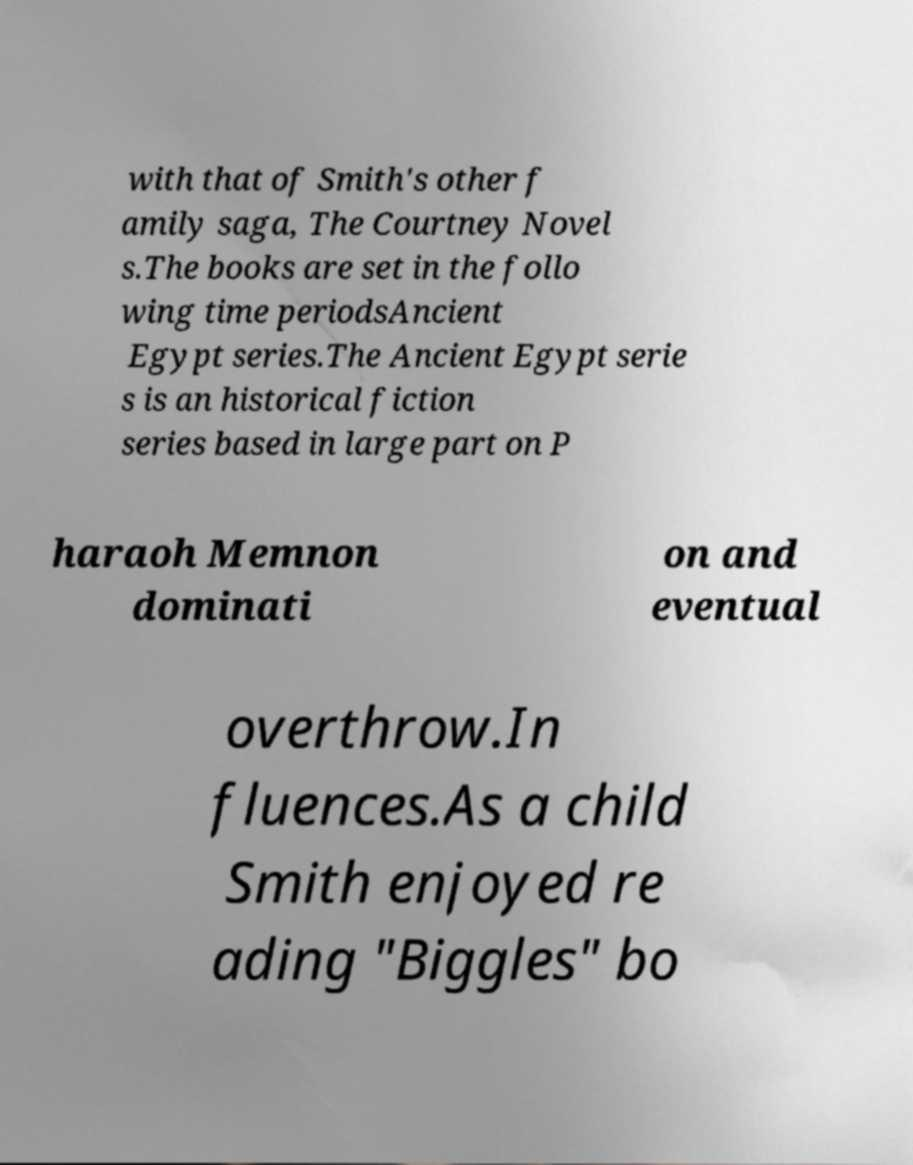For documentation purposes, I need the text within this image transcribed. Could you provide that? with that of Smith's other f amily saga, The Courtney Novel s.The books are set in the follo wing time periodsAncient Egypt series.The Ancient Egypt serie s is an historical fiction series based in large part on P haraoh Memnon dominati on and eventual overthrow.In fluences.As a child Smith enjoyed re ading "Biggles" bo 